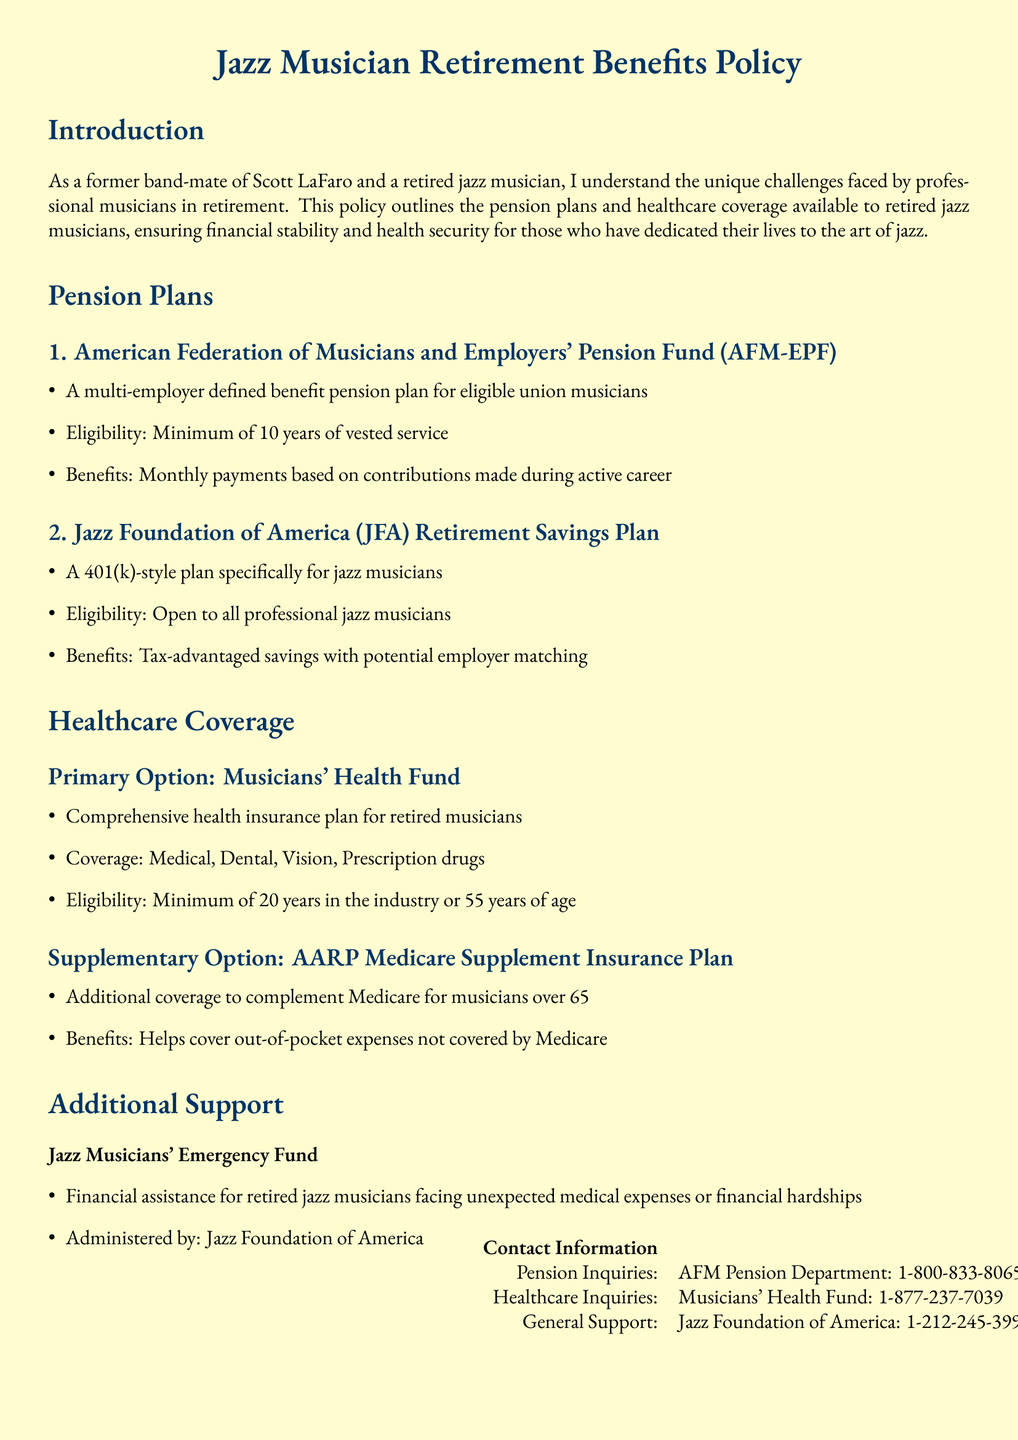What is the primary focus of this policy document? The document outlines pension plans and healthcare coverage for retired professional musicians, emphasizing their challenges in retirement.
Answer: Pension plans and healthcare coverage How many years of service are required for AFM-EPF eligibility? The eligibility criteria for AFM-EPF states a minimum of 10 years of vested service is required.
Answer: 10 years What age is the minimum for eligibility in the Musicians' Health Fund? To qualify for the Musicians' Health Fund, one must be at least 55 years of age or have a minimum of 20 years in the industry.
Answer: 55 years Name one benefit provided by the Jazz Foundation of America Retirement Savings Plan. The Jazz Foundation of America Retirement Savings Plan offers tax-advantaged savings with potential employer matching for musicians.
Answer: Tax-advantaged savings Which organization administers the Jazz Musicians' Emergency Fund? The Jazz Musicians' Emergency Fund is administered by the Jazz Foundation of America.
Answer: Jazz Foundation of America What type of insurance does the AARP Medicare Supplement Insurance Plan provide? The AARP Medicare Supplement Insurance Plan offers additional coverage to complement Medicare for musicians over 65.
Answer: Additional coverage What is the contact number for healthcare inquiries? The contact number for healthcare inquiries is 1-877-237-7039.
Answer: 1-877-237-7039 How many different pension plans are mentioned in the document? The document mentions two pension plans available for jazz musicians.
Answer: Two 